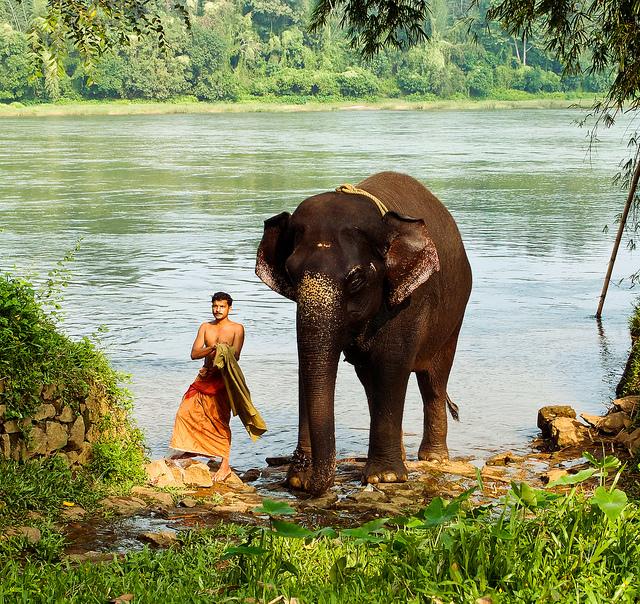Is the man wearing a shirt?
Answer briefly. No. What is hanging from the elephant's neck?
Give a very brief answer. Rope. What kind of animal is this?
Keep it brief. Elephant. Is the water muddy?
Concise answer only. No. Is the man barefoot?
Concise answer only. Yes. 